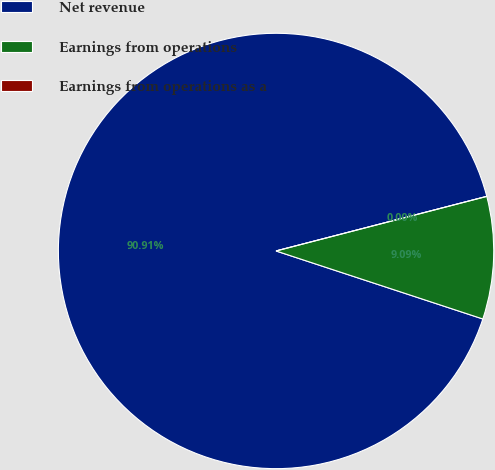Convert chart. <chart><loc_0><loc_0><loc_500><loc_500><pie_chart><fcel>Net revenue<fcel>Earnings from operations<fcel>Earnings from operations as a<nl><fcel>90.9%<fcel>9.09%<fcel>0.0%<nl></chart> 